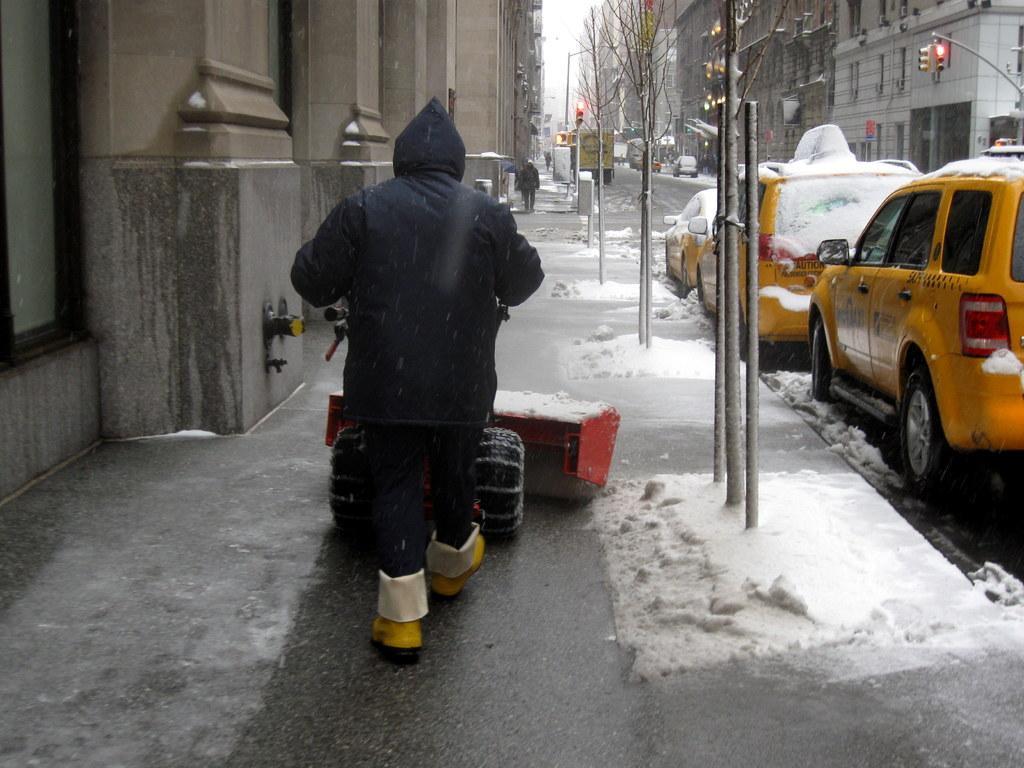Please provide a concise description of this image. In the center of the image we can see person walking on the road. On the right side of the image we can see cars, poles, signals, road and buildings. On the left side of the image we can see persons and buildings. In the background there is sky. 